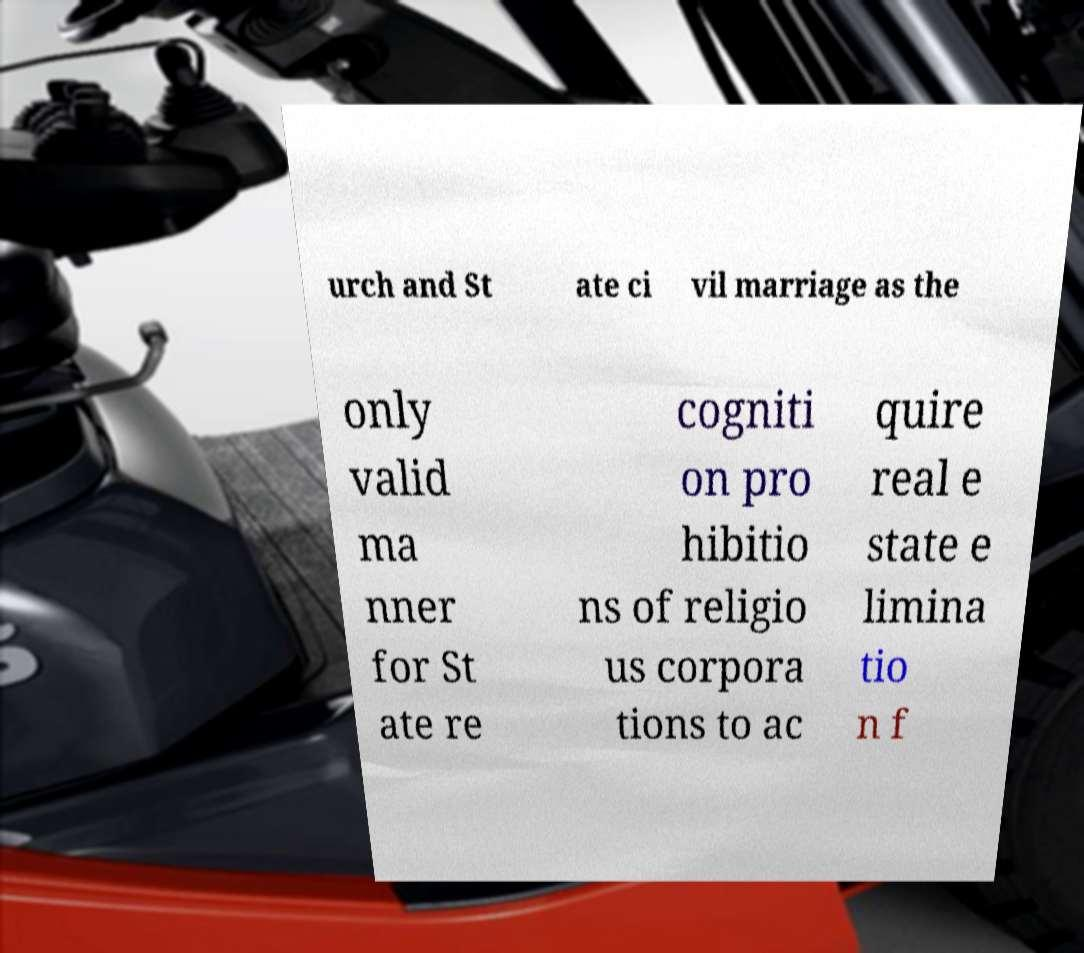Please read and relay the text visible in this image. What does it say? urch and St ate ci vil marriage as the only valid ma nner for St ate re cogniti on pro hibitio ns of religio us corpora tions to ac quire real e state e limina tio n f 